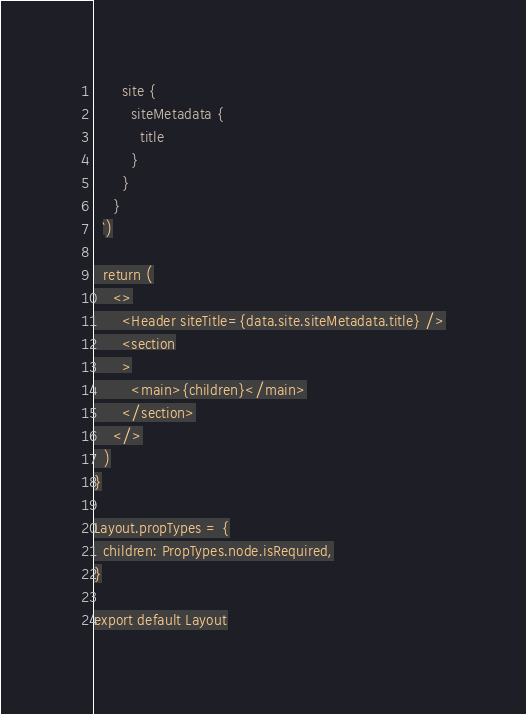Convert code to text. <code><loc_0><loc_0><loc_500><loc_500><_JavaScript_>      site {
        siteMetadata {
          title
        }
      }
    }
  `)

  return (
    <>
      <Header siteTitle={data.site.siteMetadata.title} />
      <section
      >
        <main>{children}</main>
      </section>
    </>
  )
}

Layout.propTypes = {
  children: PropTypes.node.isRequired,
}

export default Layout
</code> 